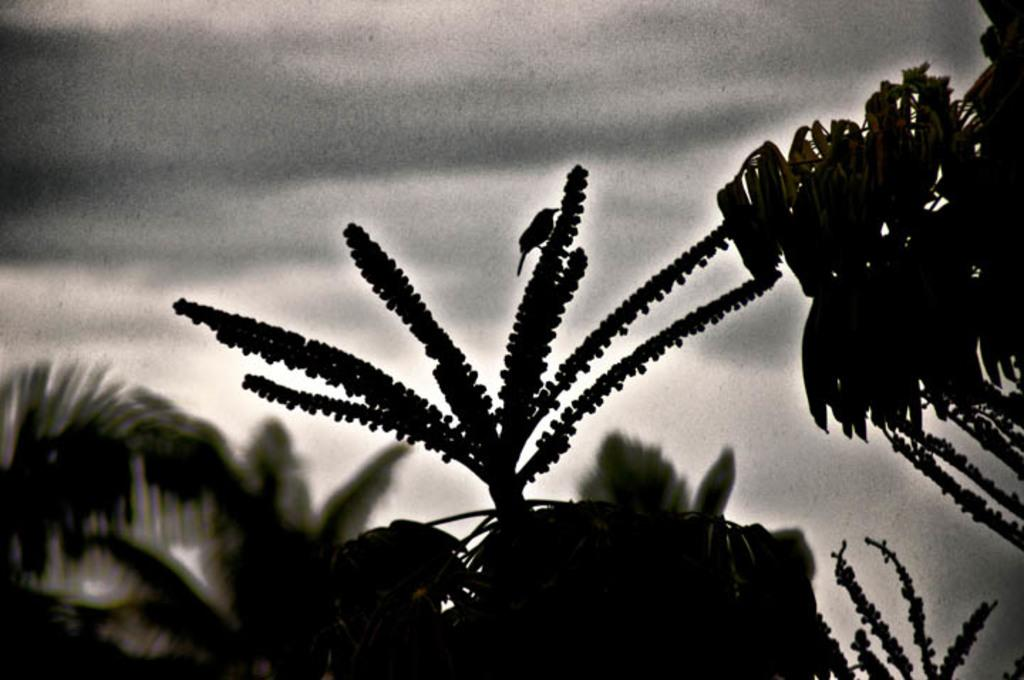What is the color scheme of the image? The image is black and white. What type of vegetation can be seen at the bottom of the image? There are trees at the bottom of the image. What is visible at the top of the image? The sky is visible at the top of the image. Can you tell me how many cameras are visible in the image? There are no cameras present in the image. What is the temperature like in the image? The image is black and white, so it does not convey temperature information. 